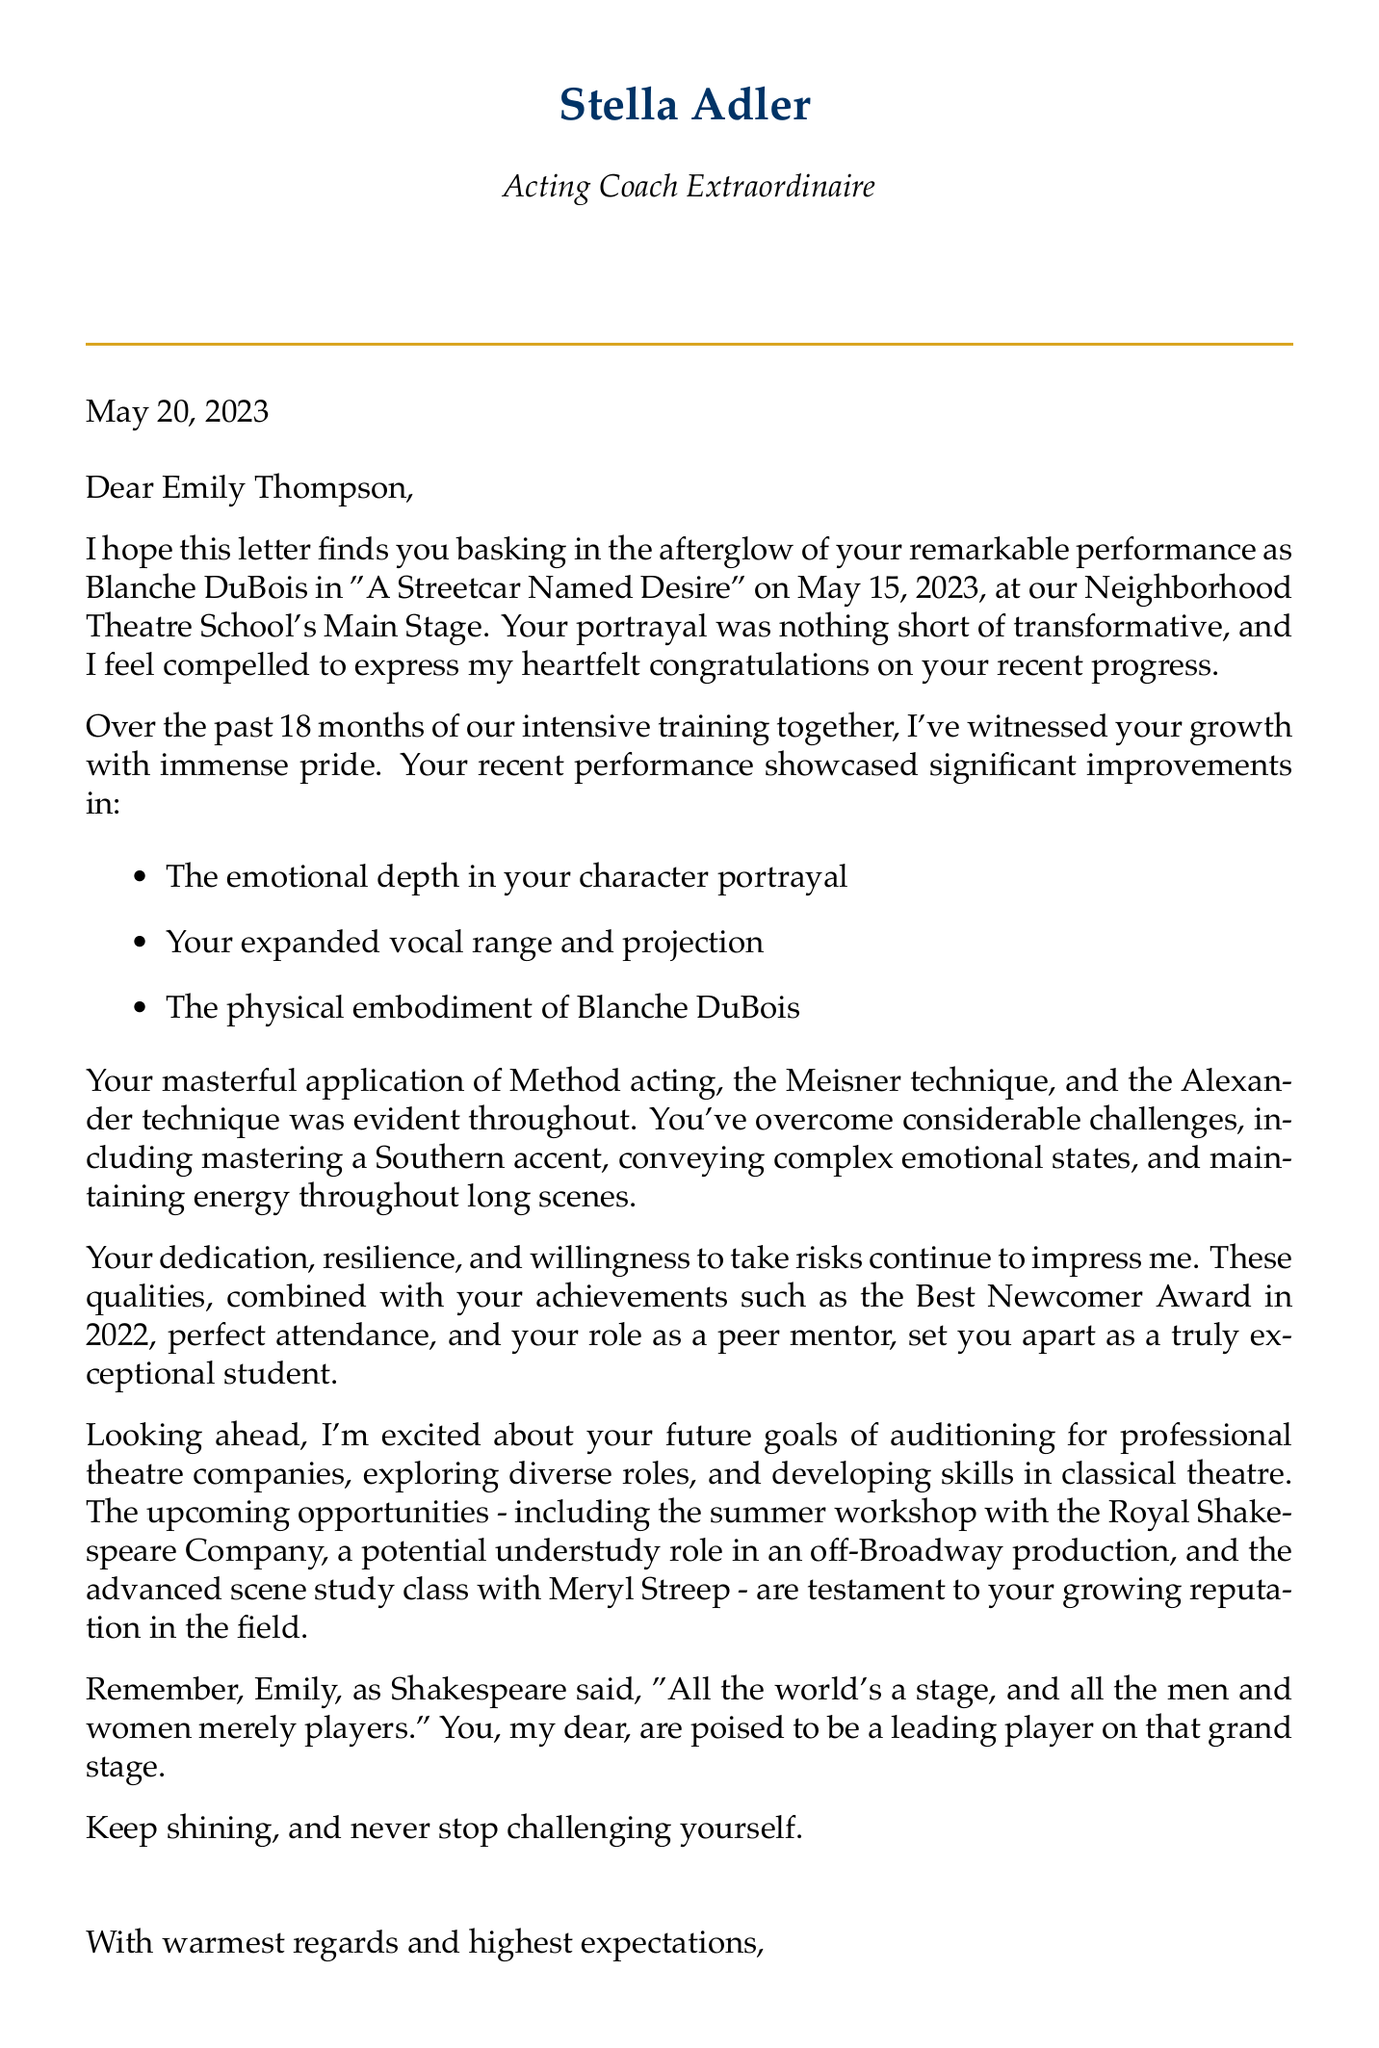What is the name of the coach? The document states that the acting coach's name is Stella Adler.
Answer: Stella Adler What is the role played by Emily Thompson? The letter mentions that Emily played the role of Blanche DuBois.
Answer: Blanche DuBois On which date did the performance take place? The document specifies that the performance occurred on May 15, 2023.
Answer: May 15, 2023 What award did Emily Thompson receive in 2022? The letter notes that Emily received the Best Newcomer Award in 2022.
Answer: Best Newcomer Award 2022 What is one technique applied by Emily during her performance? The document highlights that Method acting is one of the techniques used by Emily.
Answer: Method acting What are Emily's future goals? The letter outlines her future goals, including auditioning for professional theatre companies.
Answer: Auditioning for professional theatre companies How long has Emily been in training? The letter states that Emily has been in training for 18 months.
Answer: 18 months Who is the guest instructor for the advanced scene study class? The document mentions that Meryl Streep is the guest instructor for the class.
Answer: Meryl Streep What inspirational quote is referenced in the letter? The letter cites a quote from William Shakespeare about the world being a stage.
Answer: All the world's a stage, and all the men and women merely players 